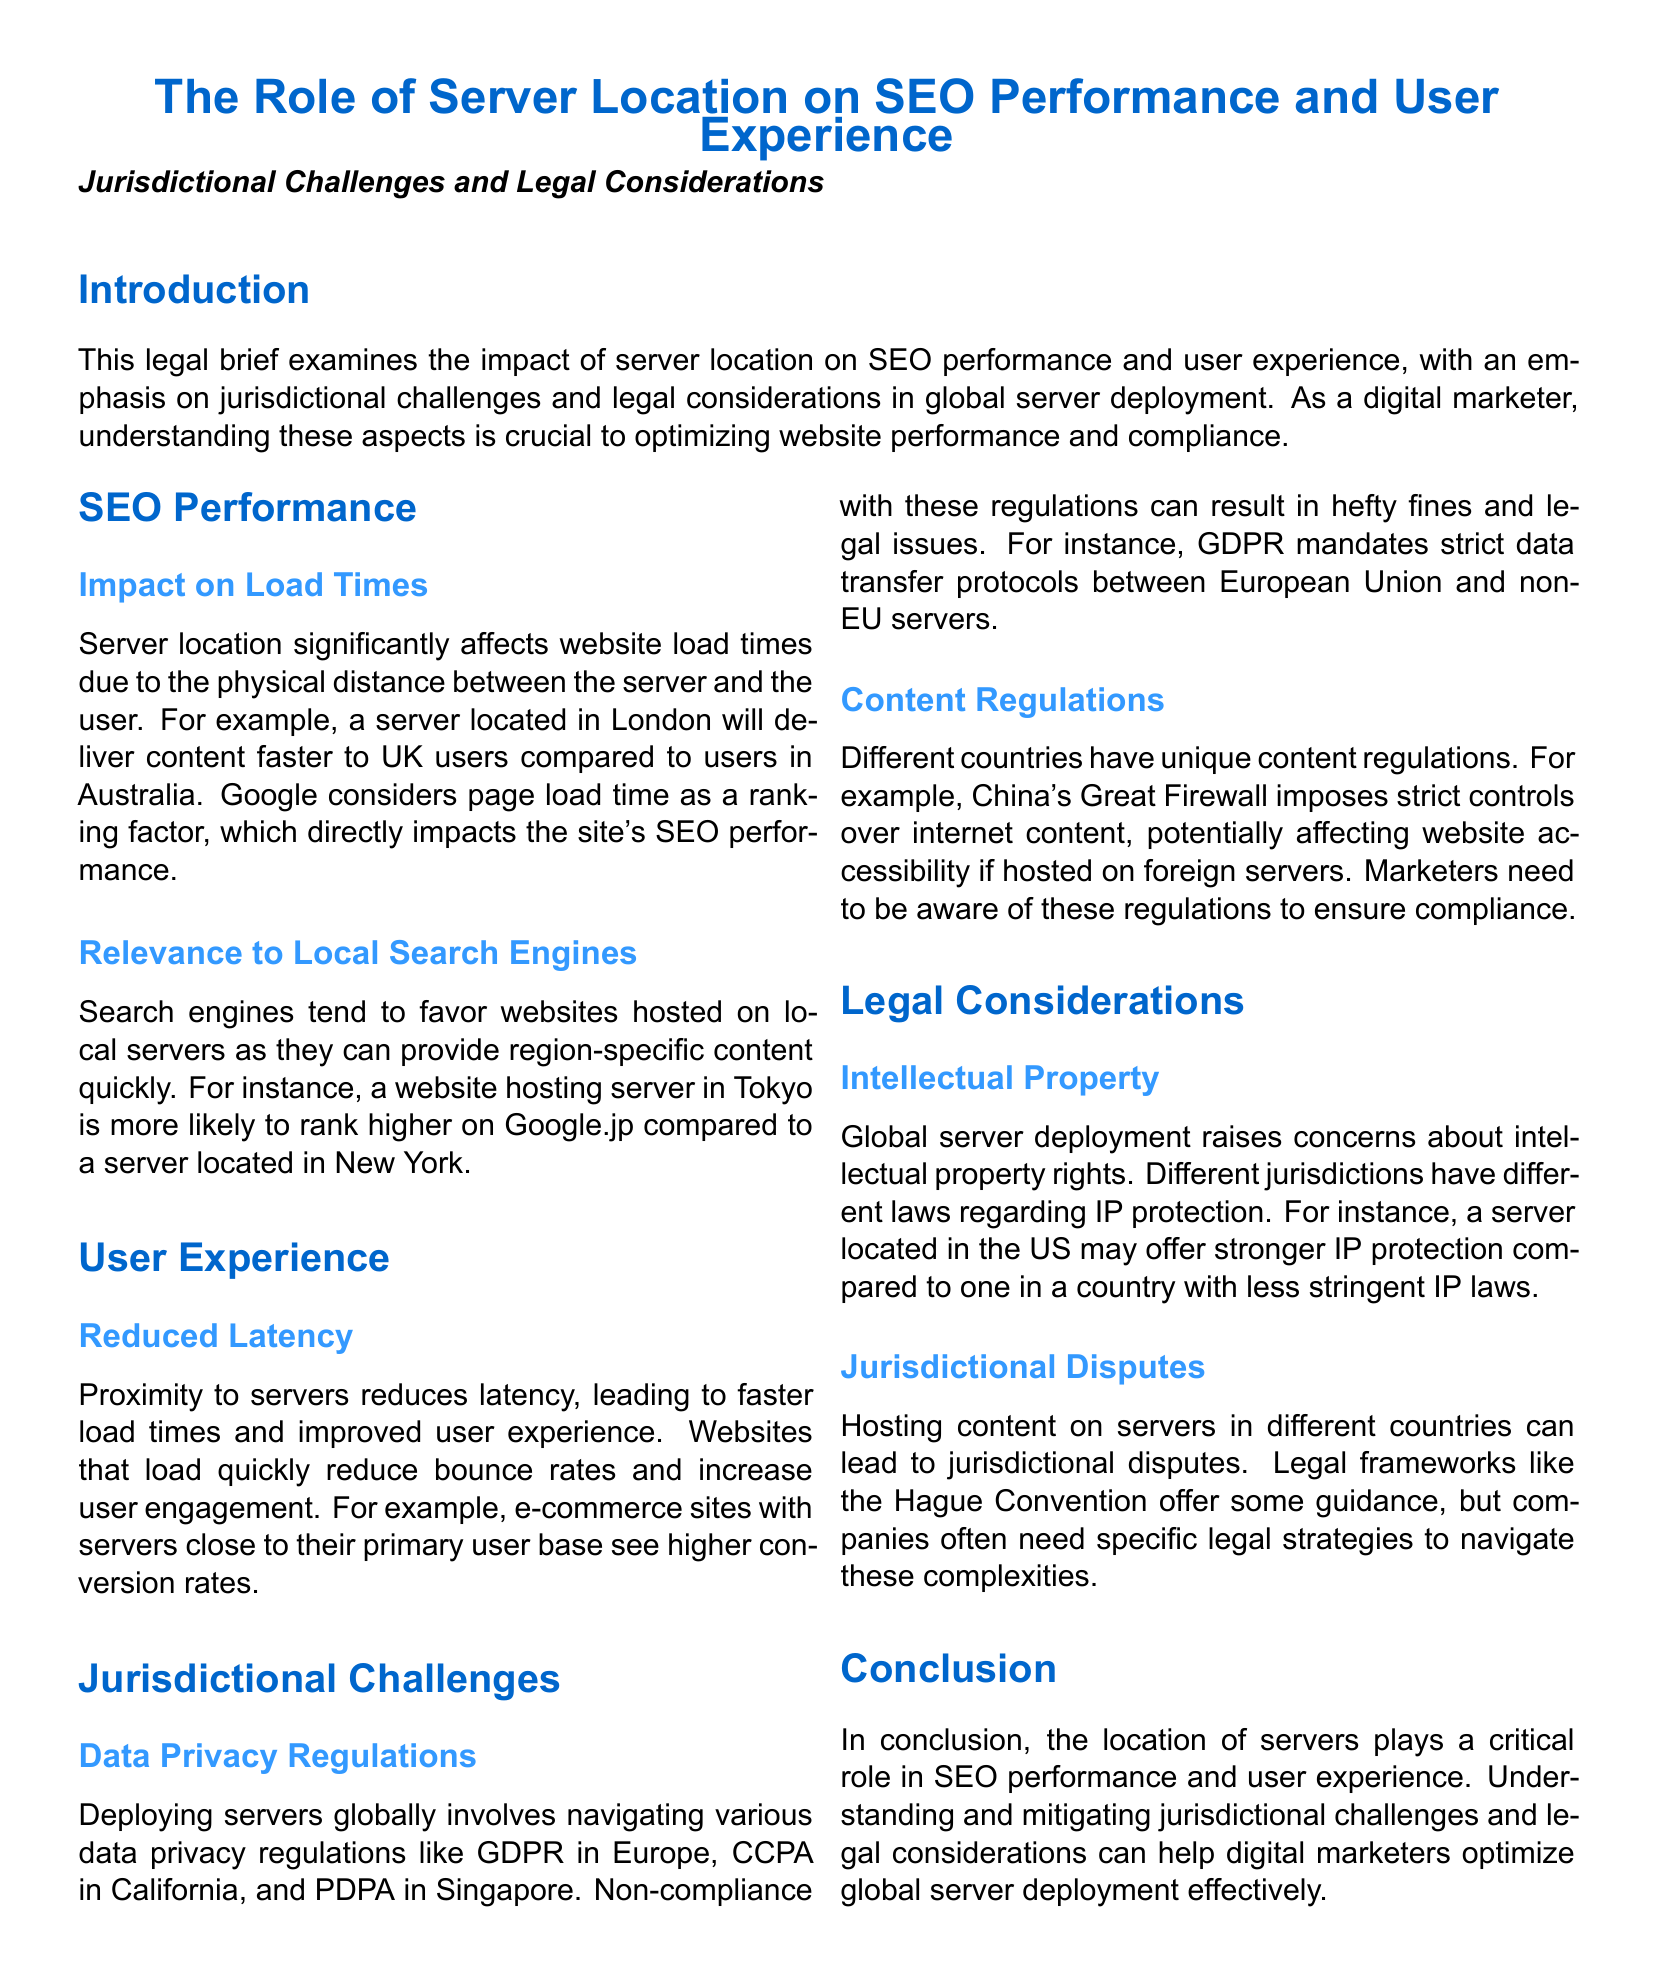What is the main focus of the legal brief? The main focus of the legal brief is the impact of server location on SEO performance and user experience, along with jurisdictional challenges and legal considerations in global server deployment.
Answer: Server location on SEO performance and user experience What does Google consider a ranking factor? Google considers page load time a ranking factor, as stated in the SEO Performance section.
Answer: Page load time What do e-commerce sites with proximate servers see? The document states that e-commerce sites with servers close to their primary user base see higher conversion rates.
Answer: Higher conversion rates What regulation must companies comply with to avoid fines in the EU? The brief mentions GDPR as a regulation that imposes strict data transfer protocols, which companies must comply with.
Answer: GDPR What does the term "Great Firewall" refer to? The term "Great Firewall" refers to China's strict controls over internet content, affecting website accessibility.
Answer: Strict controls over internet content Which legal framework offers guidance for jurisdictional disputes? The Hague Convention is mentioned as a legal framework that offers some guidance for jurisdictional disputes.
Answer: Hague Convention What is a key factor impacting local search engine favorability? The document states that search engines favor websites hosted on local servers, impacting SEO performance.
Answer: Local servers What issues may arise from intellectual property rights in global server deployment? The brief highlights concerns about differing laws regarding IP protection in different jurisdictions as a key issue.
Answer: Differing laws regarding IP protection What do non-compliance with data privacy regulations lead to? The document indicates that non-compliance can lead to hefty fines and legal issues.
Answer: Hefty fines and legal issues 